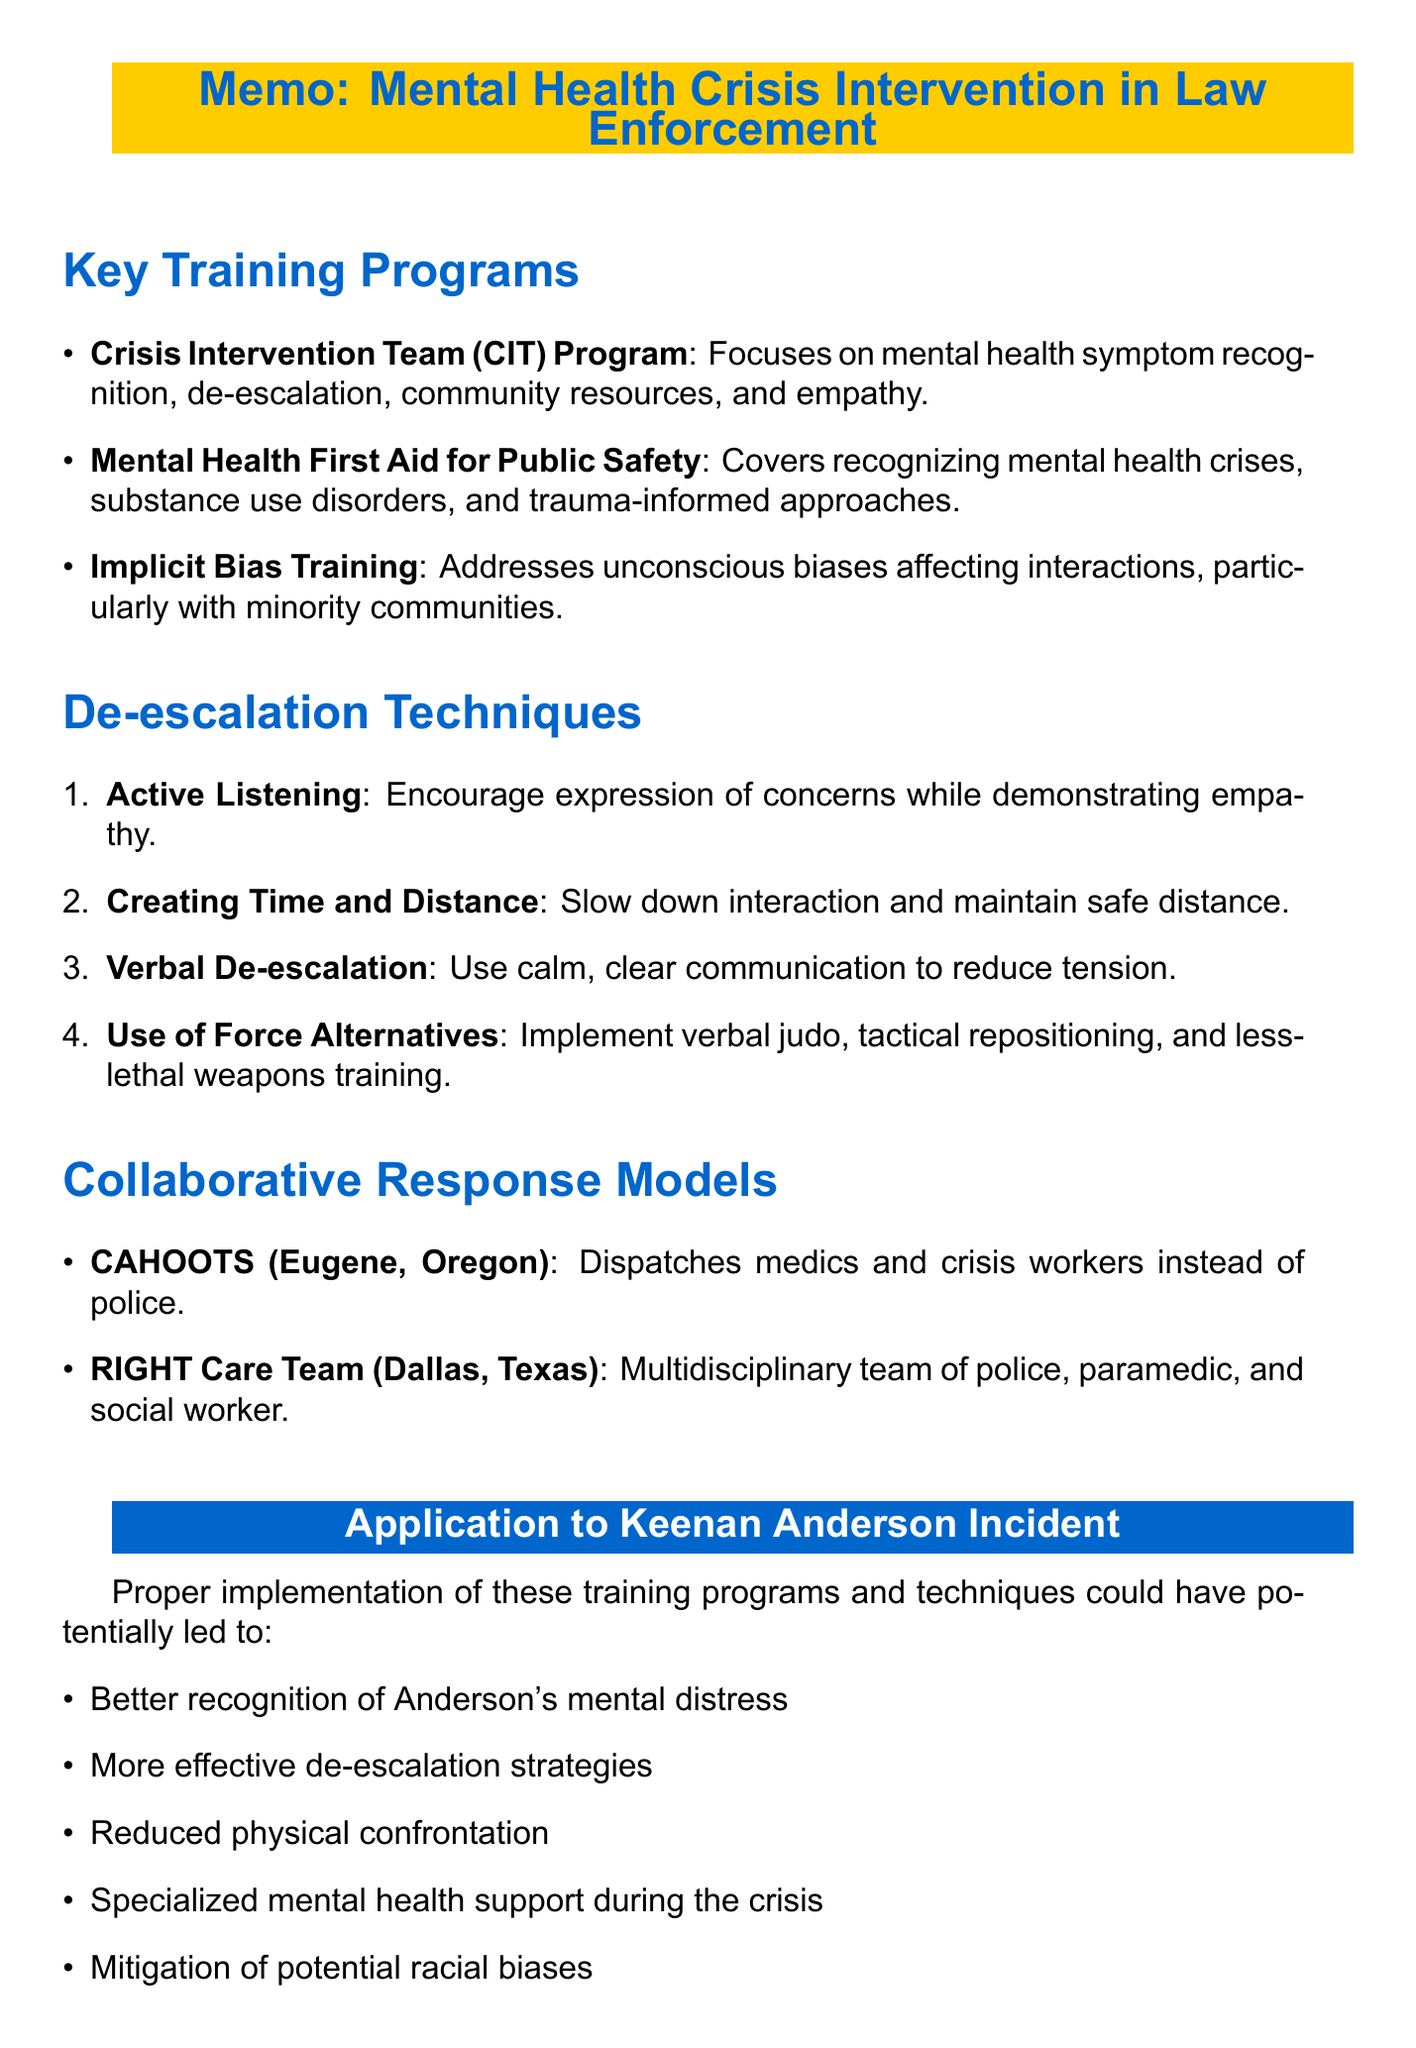what is the title of the memo? The title is stated at the top of the document as "Memo: Mental Health Crisis Intervention in Law Enforcement."
Answer: Memo: Mental Health Crisis Intervention in Law Enforcement who developed the Crisis Intervention Team (CIT) Program? The program was developed by the National Alliance on Mental Illness (NAMI) as mentioned in the document.
Answer: National Alliance on Mental Illness (NAMI) name one of the key components of the CIT Program. The document lists several key components, one of which is "De-escalation techniques."
Answer: De-escalation techniques what technique involves maintaining a safe distance during a crisis? The technique refers to "Creating Time and Distance" as outlined in the de-escalation techniques section.
Answer: Creating Time and Distance how many de-escalation techniques are listed in the document? The document enumerates four distinct de-escalation techniques in its description.
Answer: Four what is the relevance of implicit bias training in the Anderson case? The document explains that addressing potential implicit biases could lead to more equitable treatment in crisis situations.
Answer: More equitable treatment in crisis situations what type of team does the RIGHT Care Team in Dallas consist of? The document specifies that the RIGHT Care Team includes a police officer, paramedic, and social worker.
Answer: Police officer, paramedic, and social worker which program covers recognizing signs of mental health crises? The program that addresses this topic is "Mental Health First Aid for Public Safety."
Answer: Mental Health First Aid for Public Safety what is a potential impact of implementing collaborative response models? The document suggests that these models could provide specialized mental health support during crises.
Answer: Specialized mental health support during crises 